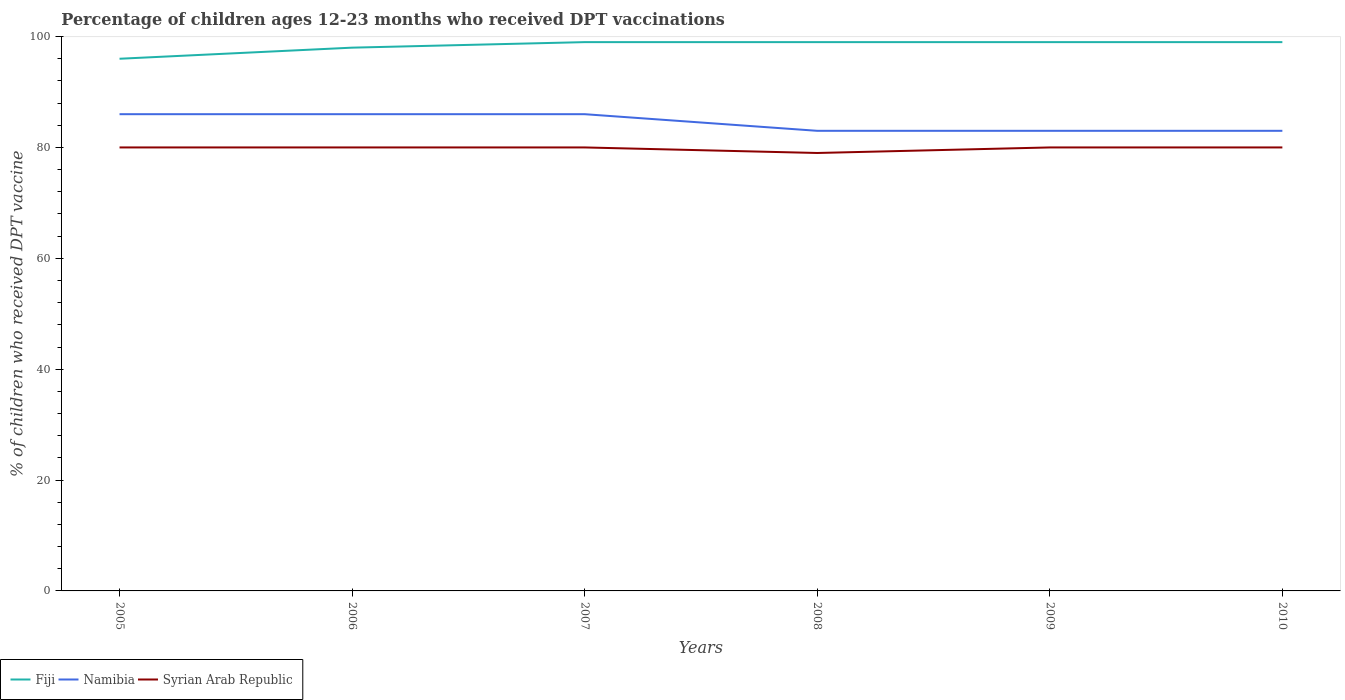How many different coloured lines are there?
Your answer should be compact. 3. Across all years, what is the maximum percentage of children who received DPT vaccination in Fiji?
Your response must be concise. 96. What is the total percentage of children who received DPT vaccination in Syrian Arab Republic in the graph?
Your answer should be very brief. 0. What is the difference between the highest and the second highest percentage of children who received DPT vaccination in Namibia?
Provide a short and direct response. 3. How many lines are there?
Provide a short and direct response. 3. What is the difference between two consecutive major ticks on the Y-axis?
Your answer should be compact. 20. Are the values on the major ticks of Y-axis written in scientific E-notation?
Keep it short and to the point. No. Does the graph contain grids?
Provide a short and direct response. No. How many legend labels are there?
Give a very brief answer. 3. How are the legend labels stacked?
Your response must be concise. Horizontal. What is the title of the graph?
Offer a terse response. Percentage of children ages 12-23 months who received DPT vaccinations. Does "Malawi" appear as one of the legend labels in the graph?
Provide a succinct answer. No. What is the label or title of the X-axis?
Provide a short and direct response. Years. What is the label or title of the Y-axis?
Your answer should be very brief. % of children who received DPT vaccine. What is the % of children who received DPT vaccine in Fiji in 2005?
Provide a short and direct response. 96. What is the % of children who received DPT vaccine in Namibia in 2005?
Ensure brevity in your answer.  86. What is the % of children who received DPT vaccine of Namibia in 2007?
Offer a terse response. 86. What is the % of children who received DPT vaccine in Syrian Arab Republic in 2007?
Ensure brevity in your answer.  80. What is the % of children who received DPT vaccine of Fiji in 2008?
Make the answer very short. 99. What is the % of children who received DPT vaccine in Namibia in 2008?
Give a very brief answer. 83. What is the % of children who received DPT vaccine in Syrian Arab Republic in 2008?
Give a very brief answer. 79. What is the % of children who received DPT vaccine in Syrian Arab Republic in 2010?
Ensure brevity in your answer.  80. Across all years, what is the maximum % of children who received DPT vaccine of Namibia?
Keep it short and to the point. 86. Across all years, what is the maximum % of children who received DPT vaccine of Syrian Arab Republic?
Provide a succinct answer. 80. Across all years, what is the minimum % of children who received DPT vaccine in Fiji?
Keep it short and to the point. 96. Across all years, what is the minimum % of children who received DPT vaccine of Syrian Arab Republic?
Offer a very short reply. 79. What is the total % of children who received DPT vaccine of Fiji in the graph?
Provide a short and direct response. 590. What is the total % of children who received DPT vaccine of Namibia in the graph?
Keep it short and to the point. 507. What is the total % of children who received DPT vaccine in Syrian Arab Republic in the graph?
Your answer should be very brief. 479. What is the difference between the % of children who received DPT vaccine of Namibia in 2005 and that in 2006?
Make the answer very short. 0. What is the difference between the % of children who received DPT vaccine of Fiji in 2005 and that in 2007?
Your response must be concise. -3. What is the difference between the % of children who received DPT vaccine of Namibia in 2005 and that in 2007?
Make the answer very short. 0. What is the difference between the % of children who received DPT vaccine in Syrian Arab Republic in 2005 and that in 2007?
Your answer should be compact. 0. What is the difference between the % of children who received DPT vaccine in Fiji in 2005 and that in 2008?
Offer a very short reply. -3. What is the difference between the % of children who received DPT vaccine of Syrian Arab Republic in 2005 and that in 2009?
Your answer should be very brief. 0. What is the difference between the % of children who received DPT vaccine of Namibia in 2005 and that in 2010?
Offer a terse response. 3. What is the difference between the % of children who received DPT vaccine of Fiji in 2006 and that in 2007?
Your response must be concise. -1. What is the difference between the % of children who received DPT vaccine of Syrian Arab Republic in 2006 and that in 2007?
Ensure brevity in your answer.  0. What is the difference between the % of children who received DPT vaccine of Namibia in 2006 and that in 2008?
Ensure brevity in your answer.  3. What is the difference between the % of children who received DPT vaccine in Fiji in 2006 and that in 2009?
Give a very brief answer. -1. What is the difference between the % of children who received DPT vaccine of Namibia in 2006 and that in 2009?
Your answer should be compact. 3. What is the difference between the % of children who received DPT vaccine of Namibia in 2006 and that in 2010?
Make the answer very short. 3. What is the difference between the % of children who received DPT vaccine of Fiji in 2007 and that in 2008?
Your answer should be compact. 0. What is the difference between the % of children who received DPT vaccine of Syrian Arab Republic in 2007 and that in 2008?
Provide a short and direct response. 1. What is the difference between the % of children who received DPT vaccine of Fiji in 2007 and that in 2009?
Your answer should be compact. 0. What is the difference between the % of children who received DPT vaccine of Namibia in 2007 and that in 2010?
Ensure brevity in your answer.  3. What is the difference between the % of children who received DPT vaccine in Syrian Arab Republic in 2007 and that in 2010?
Offer a terse response. 0. What is the difference between the % of children who received DPT vaccine of Fiji in 2008 and that in 2009?
Give a very brief answer. 0. What is the difference between the % of children who received DPT vaccine of Syrian Arab Republic in 2008 and that in 2010?
Your response must be concise. -1. What is the difference between the % of children who received DPT vaccine of Fiji in 2005 and the % of children who received DPT vaccine of Syrian Arab Republic in 2006?
Make the answer very short. 16. What is the difference between the % of children who received DPT vaccine in Namibia in 2005 and the % of children who received DPT vaccine in Syrian Arab Republic in 2006?
Keep it short and to the point. 6. What is the difference between the % of children who received DPT vaccine in Fiji in 2005 and the % of children who received DPT vaccine in Syrian Arab Republic in 2007?
Keep it short and to the point. 16. What is the difference between the % of children who received DPT vaccine of Namibia in 2005 and the % of children who received DPT vaccine of Syrian Arab Republic in 2007?
Make the answer very short. 6. What is the difference between the % of children who received DPT vaccine in Fiji in 2005 and the % of children who received DPT vaccine in Namibia in 2008?
Provide a short and direct response. 13. What is the difference between the % of children who received DPT vaccine of Fiji in 2005 and the % of children who received DPT vaccine of Syrian Arab Republic in 2008?
Give a very brief answer. 17. What is the difference between the % of children who received DPT vaccine of Fiji in 2005 and the % of children who received DPT vaccine of Namibia in 2009?
Offer a terse response. 13. What is the difference between the % of children who received DPT vaccine in Fiji in 2005 and the % of children who received DPT vaccine in Syrian Arab Republic in 2009?
Provide a short and direct response. 16. What is the difference between the % of children who received DPT vaccine in Namibia in 2005 and the % of children who received DPT vaccine in Syrian Arab Republic in 2010?
Your response must be concise. 6. What is the difference between the % of children who received DPT vaccine of Fiji in 2006 and the % of children who received DPT vaccine of Namibia in 2007?
Offer a terse response. 12. What is the difference between the % of children who received DPT vaccine of Fiji in 2006 and the % of children who received DPT vaccine of Syrian Arab Republic in 2007?
Your response must be concise. 18. What is the difference between the % of children who received DPT vaccine in Namibia in 2006 and the % of children who received DPT vaccine in Syrian Arab Republic in 2007?
Provide a succinct answer. 6. What is the difference between the % of children who received DPT vaccine in Fiji in 2006 and the % of children who received DPT vaccine in Namibia in 2008?
Keep it short and to the point. 15. What is the difference between the % of children who received DPT vaccine of Fiji in 2006 and the % of children who received DPT vaccine of Syrian Arab Republic in 2008?
Provide a short and direct response. 19. What is the difference between the % of children who received DPT vaccine of Namibia in 2006 and the % of children who received DPT vaccine of Syrian Arab Republic in 2008?
Keep it short and to the point. 7. What is the difference between the % of children who received DPT vaccine of Fiji in 2006 and the % of children who received DPT vaccine of Namibia in 2009?
Make the answer very short. 15. What is the difference between the % of children who received DPT vaccine of Namibia in 2006 and the % of children who received DPT vaccine of Syrian Arab Republic in 2009?
Give a very brief answer. 6. What is the difference between the % of children who received DPT vaccine of Fiji in 2006 and the % of children who received DPT vaccine of Namibia in 2010?
Ensure brevity in your answer.  15. What is the difference between the % of children who received DPT vaccine in Namibia in 2006 and the % of children who received DPT vaccine in Syrian Arab Republic in 2010?
Give a very brief answer. 6. What is the difference between the % of children who received DPT vaccine of Fiji in 2007 and the % of children who received DPT vaccine of Syrian Arab Republic in 2008?
Make the answer very short. 20. What is the difference between the % of children who received DPT vaccine in Fiji in 2007 and the % of children who received DPT vaccine in Syrian Arab Republic in 2009?
Ensure brevity in your answer.  19. What is the difference between the % of children who received DPT vaccine of Fiji in 2007 and the % of children who received DPT vaccine of Syrian Arab Republic in 2010?
Your answer should be very brief. 19. What is the difference between the % of children who received DPT vaccine in Namibia in 2007 and the % of children who received DPT vaccine in Syrian Arab Republic in 2010?
Give a very brief answer. 6. What is the difference between the % of children who received DPT vaccine of Fiji in 2008 and the % of children who received DPT vaccine of Namibia in 2010?
Provide a succinct answer. 16. What is the difference between the % of children who received DPT vaccine in Namibia in 2008 and the % of children who received DPT vaccine in Syrian Arab Republic in 2010?
Your answer should be very brief. 3. What is the difference between the % of children who received DPT vaccine of Fiji in 2009 and the % of children who received DPT vaccine of Namibia in 2010?
Ensure brevity in your answer.  16. What is the difference between the % of children who received DPT vaccine of Namibia in 2009 and the % of children who received DPT vaccine of Syrian Arab Republic in 2010?
Provide a short and direct response. 3. What is the average % of children who received DPT vaccine in Fiji per year?
Your answer should be compact. 98.33. What is the average % of children who received DPT vaccine of Namibia per year?
Make the answer very short. 84.5. What is the average % of children who received DPT vaccine in Syrian Arab Republic per year?
Your response must be concise. 79.83. In the year 2005, what is the difference between the % of children who received DPT vaccine in Fiji and % of children who received DPT vaccine in Namibia?
Your response must be concise. 10. In the year 2006, what is the difference between the % of children who received DPT vaccine of Fiji and % of children who received DPT vaccine of Syrian Arab Republic?
Your response must be concise. 18. In the year 2007, what is the difference between the % of children who received DPT vaccine of Fiji and % of children who received DPT vaccine of Syrian Arab Republic?
Give a very brief answer. 19. In the year 2008, what is the difference between the % of children who received DPT vaccine of Fiji and % of children who received DPT vaccine of Namibia?
Provide a succinct answer. 16. In the year 2008, what is the difference between the % of children who received DPT vaccine in Fiji and % of children who received DPT vaccine in Syrian Arab Republic?
Provide a short and direct response. 20. In the year 2009, what is the difference between the % of children who received DPT vaccine of Fiji and % of children who received DPT vaccine of Namibia?
Ensure brevity in your answer.  16. In the year 2009, what is the difference between the % of children who received DPT vaccine of Namibia and % of children who received DPT vaccine of Syrian Arab Republic?
Make the answer very short. 3. In the year 2010, what is the difference between the % of children who received DPT vaccine of Namibia and % of children who received DPT vaccine of Syrian Arab Republic?
Keep it short and to the point. 3. What is the ratio of the % of children who received DPT vaccine in Fiji in 2005 to that in 2006?
Offer a very short reply. 0.98. What is the ratio of the % of children who received DPT vaccine of Namibia in 2005 to that in 2006?
Your answer should be very brief. 1. What is the ratio of the % of children who received DPT vaccine in Fiji in 2005 to that in 2007?
Make the answer very short. 0.97. What is the ratio of the % of children who received DPT vaccine in Fiji in 2005 to that in 2008?
Your answer should be compact. 0.97. What is the ratio of the % of children who received DPT vaccine of Namibia in 2005 to that in 2008?
Make the answer very short. 1.04. What is the ratio of the % of children who received DPT vaccine in Syrian Arab Republic in 2005 to that in 2008?
Offer a terse response. 1.01. What is the ratio of the % of children who received DPT vaccine of Fiji in 2005 to that in 2009?
Provide a short and direct response. 0.97. What is the ratio of the % of children who received DPT vaccine of Namibia in 2005 to that in 2009?
Your response must be concise. 1.04. What is the ratio of the % of children who received DPT vaccine of Fiji in 2005 to that in 2010?
Keep it short and to the point. 0.97. What is the ratio of the % of children who received DPT vaccine of Namibia in 2005 to that in 2010?
Offer a terse response. 1.04. What is the ratio of the % of children who received DPT vaccine of Fiji in 2006 to that in 2007?
Offer a very short reply. 0.99. What is the ratio of the % of children who received DPT vaccine in Namibia in 2006 to that in 2008?
Your answer should be very brief. 1.04. What is the ratio of the % of children who received DPT vaccine of Syrian Arab Republic in 2006 to that in 2008?
Your answer should be very brief. 1.01. What is the ratio of the % of children who received DPT vaccine of Fiji in 2006 to that in 2009?
Give a very brief answer. 0.99. What is the ratio of the % of children who received DPT vaccine in Namibia in 2006 to that in 2009?
Provide a short and direct response. 1.04. What is the ratio of the % of children who received DPT vaccine in Namibia in 2006 to that in 2010?
Make the answer very short. 1.04. What is the ratio of the % of children who received DPT vaccine in Syrian Arab Republic in 2006 to that in 2010?
Keep it short and to the point. 1. What is the ratio of the % of children who received DPT vaccine of Fiji in 2007 to that in 2008?
Make the answer very short. 1. What is the ratio of the % of children who received DPT vaccine in Namibia in 2007 to that in 2008?
Keep it short and to the point. 1.04. What is the ratio of the % of children who received DPT vaccine in Syrian Arab Republic in 2007 to that in 2008?
Offer a very short reply. 1.01. What is the ratio of the % of children who received DPT vaccine of Namibia in 2007 to that in 2009?
Your response must be concise. 1.04. What is the ratio of the % of children who received DPT vaccine of Namibia in 2007 to that in 2010?
Make the answer very short. 1.04. What is the ratio of the % of children who received DPT vaccine of Syrian Arab Republic in 2007 to that in 2010?
Ensure brevity in your answer.  1. What is the ratio of the % of children who received DPT vaccine of Namibia in 2008 to that in 2009?
Keep it short and to the point. 1. What is the ratio of the % of children who received DPT vaccine in Syrian Arab Republic in 2008 to that in 2009?
Provide a succinct answer. 0.99. What is the ratio of the % of children who received DPT vaccine of Fiji in 2008 to that in 2010?
Your answer should be compact. 1. What is the ratio of the % of children who received DPT vaccine of Syrian Arab Republic in 2008 to that in 2010?
Provide a succinct answer. 0.99. What is the difference between the highest and the second highest % of children who received DPT vaccine of Namibia?
Provide a short and direct response. 0. What is the difference between the highest and the second highest % of children who received DPT vaccine of Syrian Arab Republic?
Your response must be concise. 0. What is the difference between the highest and the lowest % of children who received DPT vaccine of Fiji?
Your response must be concise. 3. What is the difference between the highest and the lowest % of children who received DPT vaccine of Namibia?
Provide a short and direct response. 3. What is the difference between the highest and the lowest % of children who received DPT vaccine of Syrian Arab Republic?
Make the answer very short. 1. 